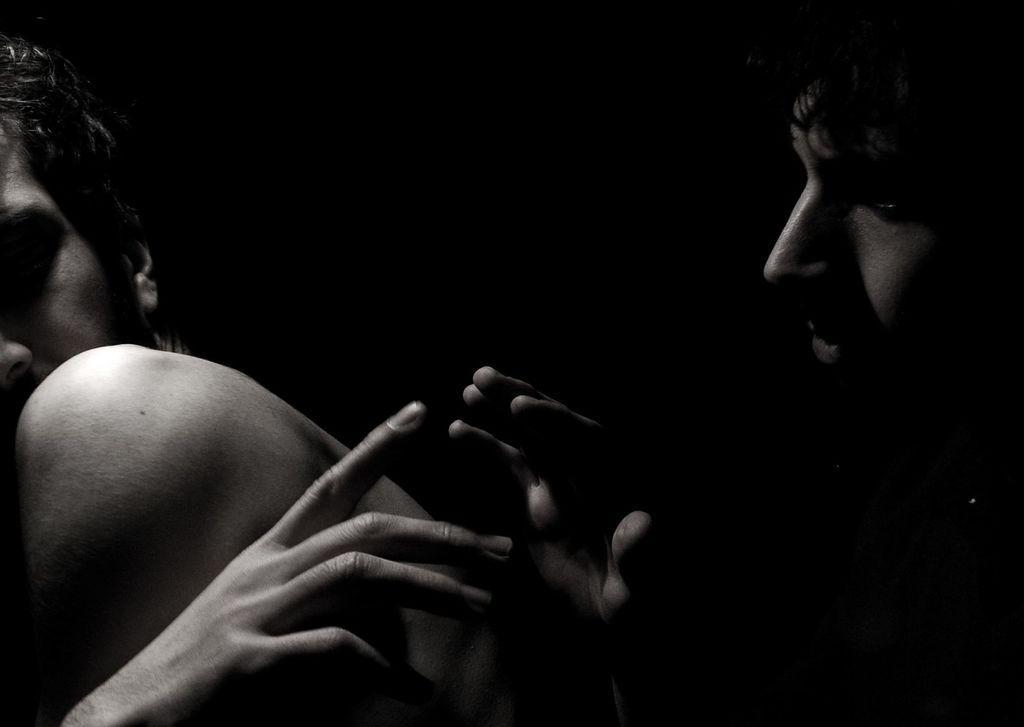How would you summarize this image in a sentence or two? This is a black and white image, in this image there are two men. 